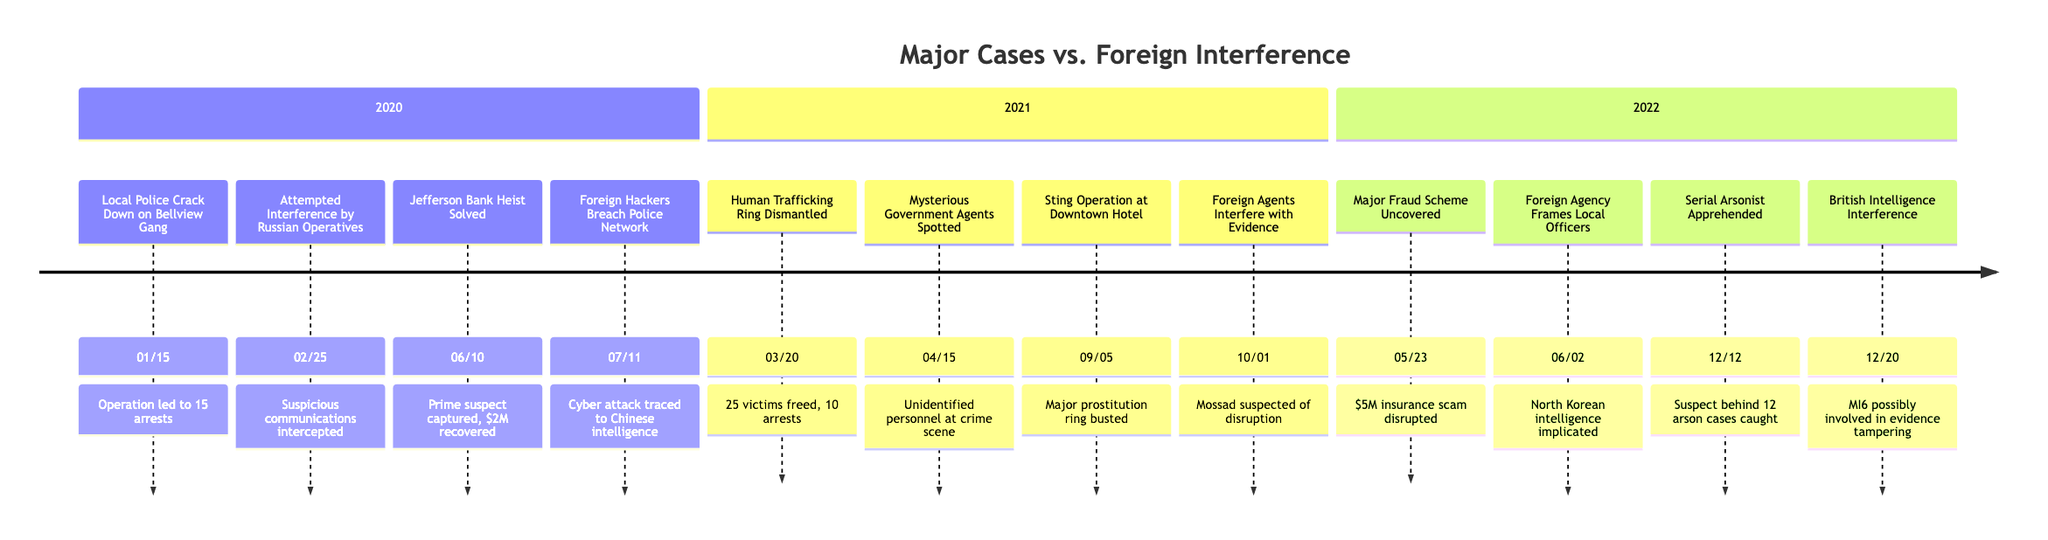What event occurred first in 2021? The diagram lists events chronologically. Scanning through the events in 2021, the first one is on March 20, which is the "Human Trafficking Ring Dismantled."
Answer: Human Trafficking Ring Dismantled How many major cases did the local police handle in 2022? Looking at the events listed for 2022, there are four major cases: "Major Fraud Scheme Uncovered," "Serial Arsonist Apprehended," "Foreign Agency Frames Local Officers," and "British Intelligence Interference."
Answer: 4 Which foreign agency was involved in a cyber attack? Inspecting the entries, the event "Foreign Hackers Breach Police Network" on July 11, 2020, specifies that the cyber attack was traced to a group associated with Chinese intelligence.
Answer: Chinese intelligence What was the result of the Jefferson Bank Heist case? The details for "Jefferson Bank Heist Solved" on June 10, 2020, indicate that the local police captured the prime suspect and recovered a significant portion of the stolen $2 million.
Answer: $2 million Which event is related to a major prostitution ring? The event "Sting Operation at Downtown Hotel" on September 5, 2021, directly pertains to the busting of a major prostitution ring, apprehending 30 individuals.
Answer: Sting Operation at Downtown Hotel What is the common theme of the events listed in the timeline? Analyzing the events listed, they all involve either significant actions taken by the local police force or attempts to interfere from foreign agencies, showcasing a conflict of interests in law enforcement.
Answer: Police actions vs. foreign interference How many reports of foreign interference were listed in 2020? The timeline outlines two events of foreign interference in 2020: "Attempted Interference by Foreign Agency" and "Foreign Hackers Breach Police Network," totaling two reports.
Answer: 2 Which event involved unidentified personnel observed at a crime scene? The event "Mysterious Government Agents Spotted" on April 15, 2021, details the presence of unmarked vehicles and unidentified personnel at a crime scene, believed to be foreign agents.
Answer: Mysterious Government Agents Spotted 